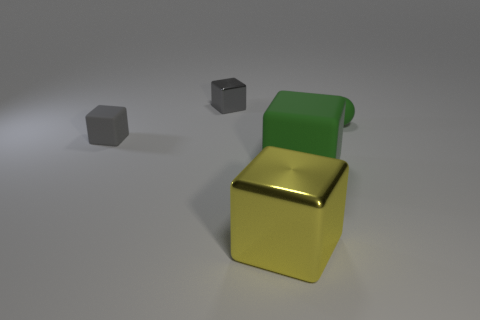What time of day does the lighting in the scene suggest? The diffused lighting and soft shadows in the image could be suggestive of an overcast day or an indoor setting with strong, ambient artificial lighting, lacking the harshness of direct sunlight. 